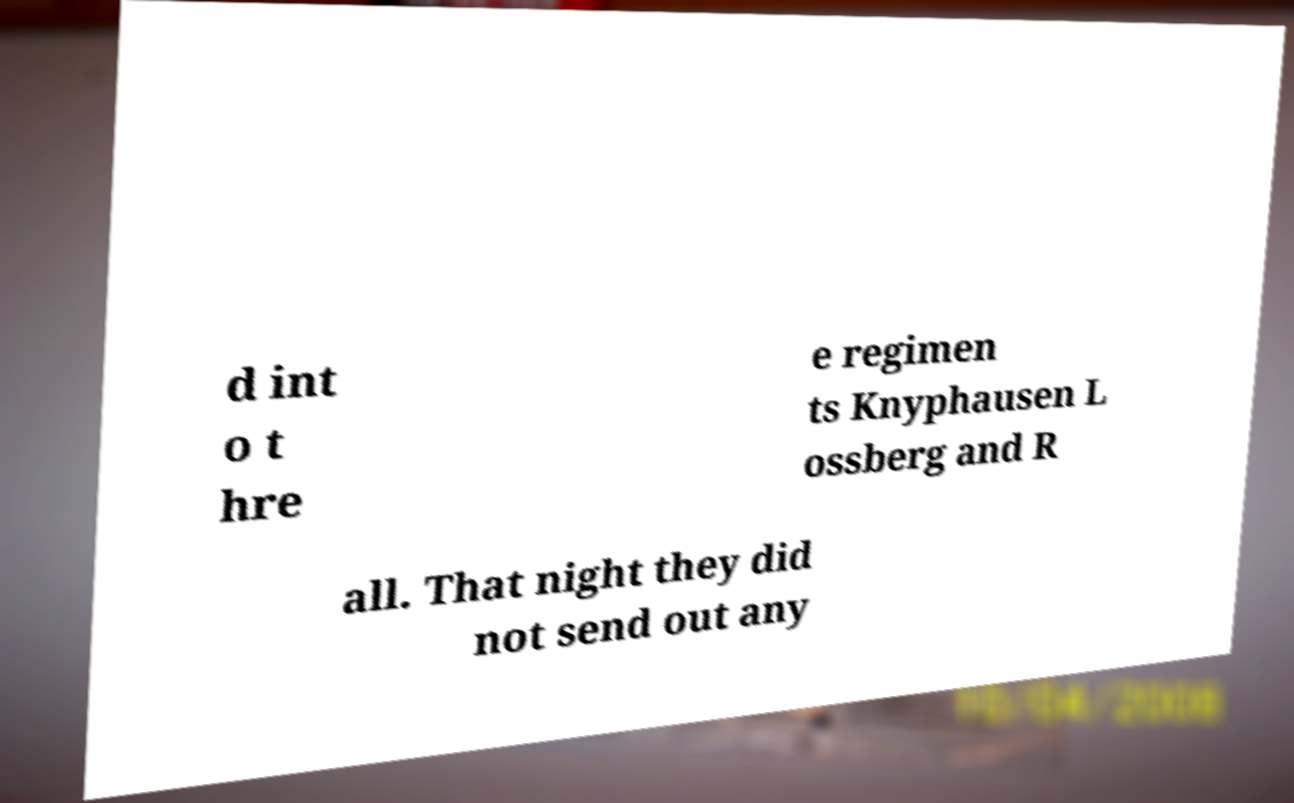Can you accurately transcribe the text from the provided image for me? d int o t hre e regimen ts Knyphausen L ossberg and R all. That night they did not send out any 